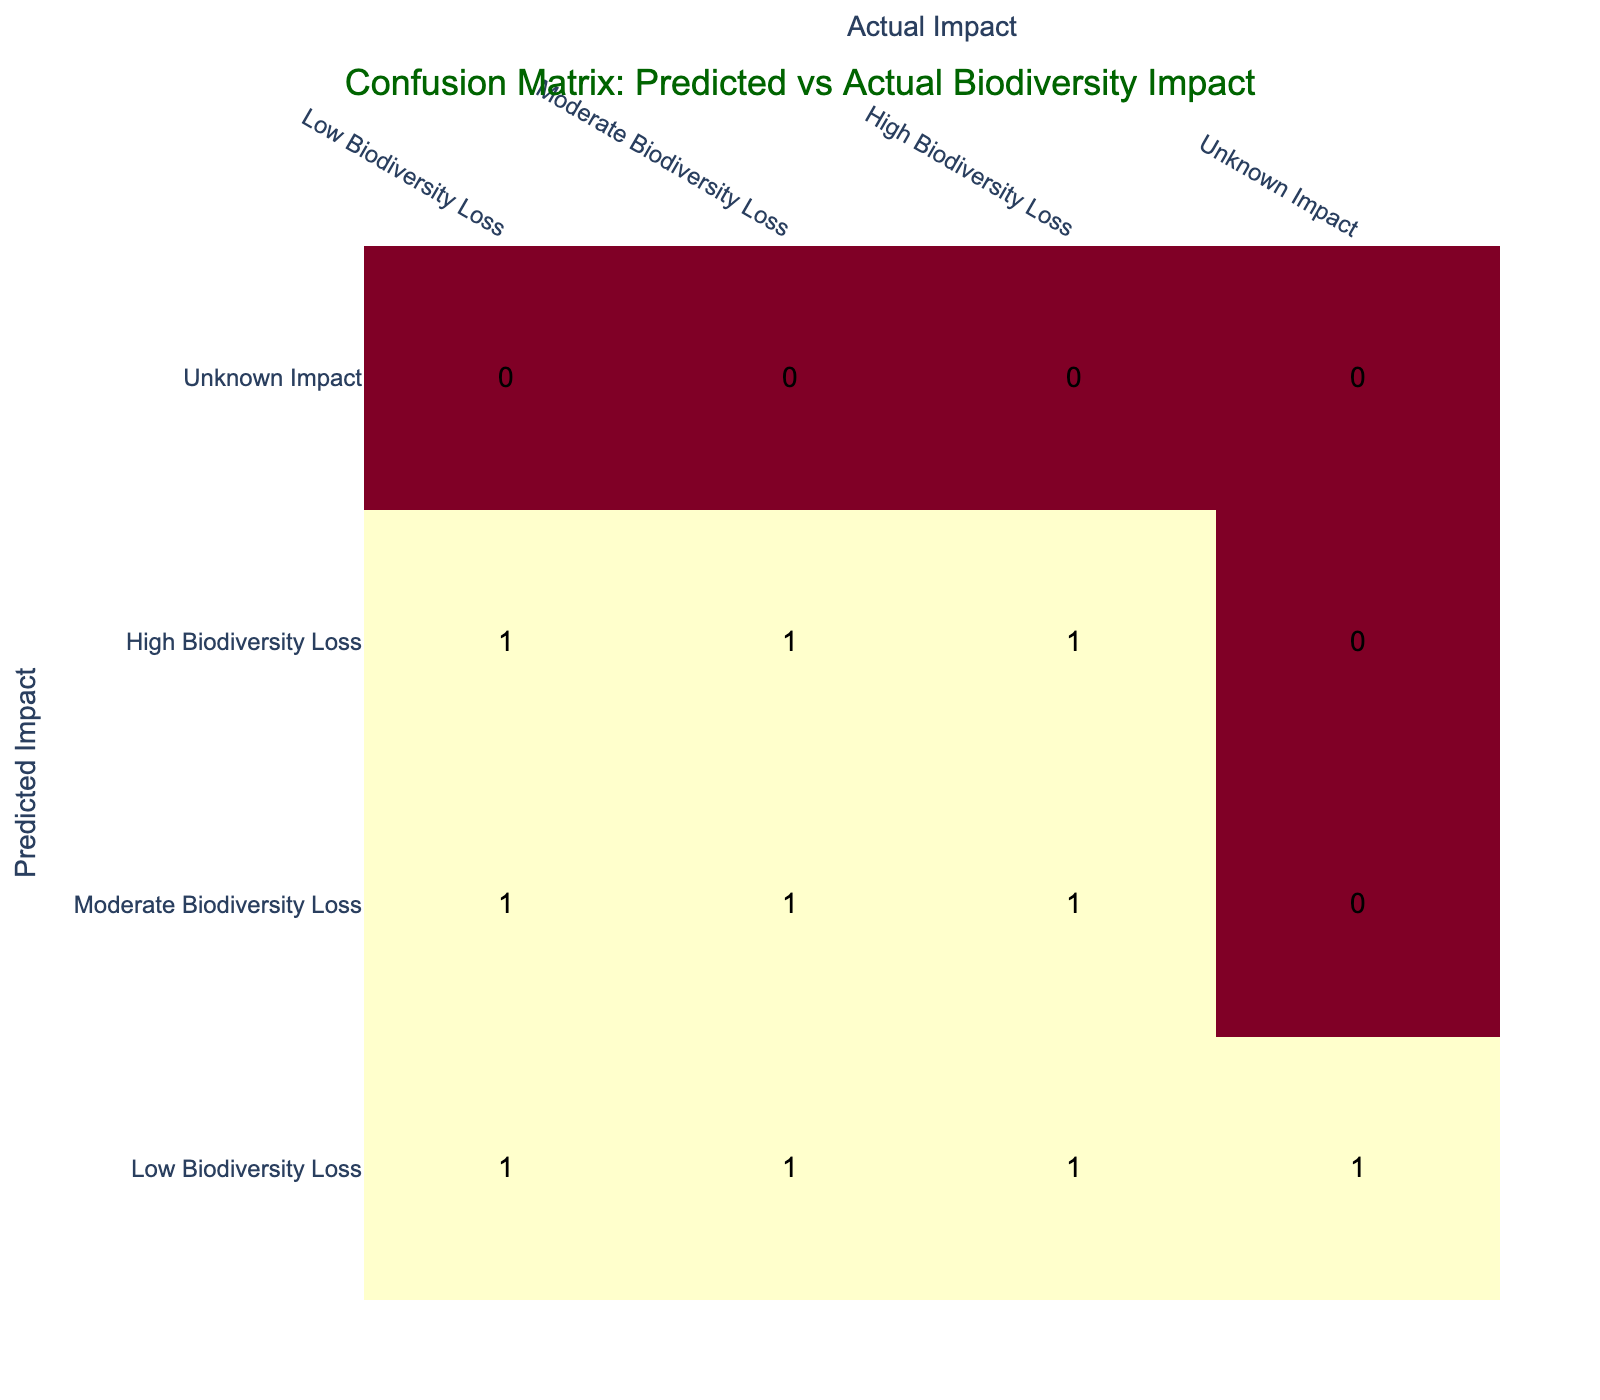What is the predicted impact for actual low biodiversity loss? The table shows that the actual low biodiversity loss has a predicted impact count of 1 from the "Low Biodiversity Loss" row.
Answer: Low Biodiversity Loss How many instances are there where the predicted impact was moderate biodiversity loss? From the table, I can see there are 2 instances where the predicted impact is moderate biodiversity loss (one for low actual impact and one for high actual impact).
Answer: 2 Is it true that high biodiversity loss was always predicted when actual biodiversity loss was high? The table shows that when actual biodiversity loss was high, the predicted impact was high in 2 instances and moderate in 1 instance. Therefore, it's not true that high biodiversity loss was always predicted when actual biodiversity loss was high.
Answer: No What is the total count of cases where the predicted impact was classified as low biodiversity loss? By counting the "Low Biodiversity Loss" row, there are 4 instances where the predicted impact was classified as low biodiversity loss.
Answer: 4 What percentage of total predictions resulted in a correct identification of moderate biodiversity loss? Correct identification of moderate biodiversity loss occurs when the predicted impact also matches the actual impact (1 instance). The total number of predictions is 10. Therefore, (1/10) * 100 = 10%.
Answer: 10% How many instances result in an unknown impact when the predicted impact was low biodiversity loss? In the table, there is 1 instance where the predicted impact is low biodiversity loss and the actual impact is unknown.
Answer: 1 How many total incorrect predictions were made? Total incorrect predictions are calculated by adding all off-diagonal elements in the confusion matrix: (1 from low predicted, high actual) + (1 from moderate predicted, low actual) + (1 from high predicted, moderate actual) + (1 from moderate predicted, high actual) + (1 from high predicted, low actual) + (1 from low predicted, unknown) = 6 instances.
Answer: 6 What is the most common predicted impact? By analyzing the rows, the predicted impact of low biodiversity loss appears most frequently with 4 instances.
Answer: Low Biodiversity Loss 